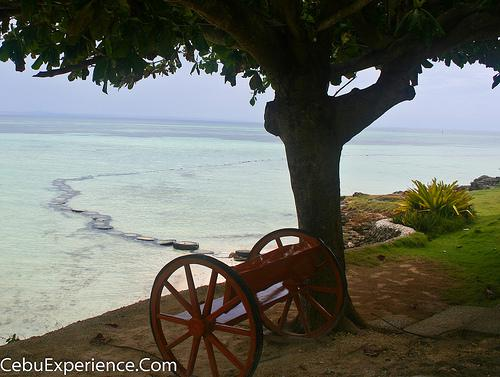Question: what color is the bench?
Choices:
A. Yellow.
B. Brown.
C. Black.
D. Red.
Answer with the letter. Answer: D Question: what is the tall thing in the middle?
Choices:
A. Pole.
B. Lamp post.
C. Crane.
D. Tree.
Answer with the letter. Answer: D Question: what is on the edges of the bench?
Choices:
A. Wheels.
B. Tail.
C. Propeller.
D. Sled.
Answer with the letter. Answer: A 